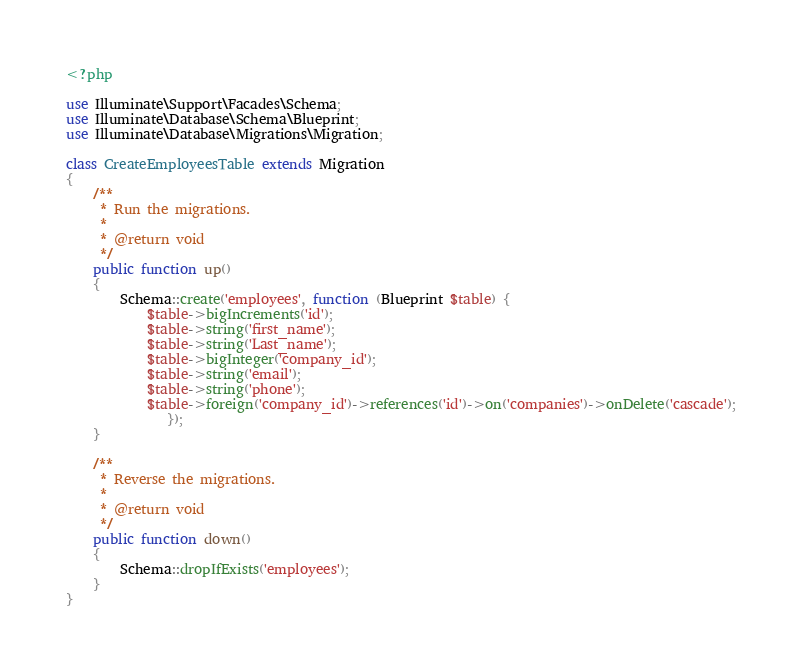<code> <loc_0><loc_0><loc_500><loc_500><_PHP_><?php

use Illuminate\Support\Facades\Schema;
use Illuminate\Database\Schema\Blueprint;
use Illuminate\Database\Migrations\Migration;

class CreateEmployeesTable extends Migration
{
    /**
     * Run the migrations.
     *
     * @return void
     */
    public function up()
    {
        Schema::create('employees', function (Blueprint $table) {
            $table->bigIncrements('id');
            $table->string('first_name');
            $table->string('Last_name');
            $table->bigInteger('company_id');
            $table->string('email');
            $table->string('phone');
            $table->foreign('company_id')->references('id')->on('companies')->onDelete('cascade');
               });
    }

    /**
     * Reverse the migrations.
     *
     * @return void
     */
    public function down()
    {
        Schema::dropIfExists('employees');
    }
}
</code> 